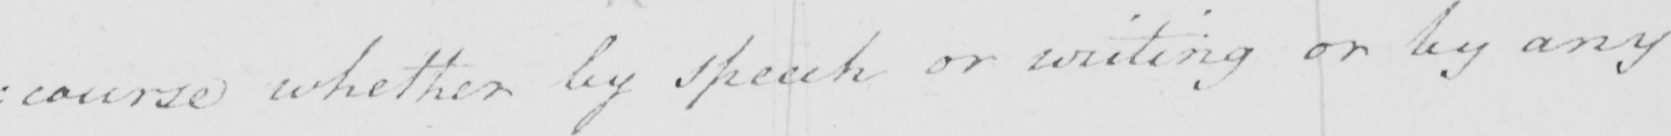What is written in this line of handwriting? : course whether by speech or writing or by any 